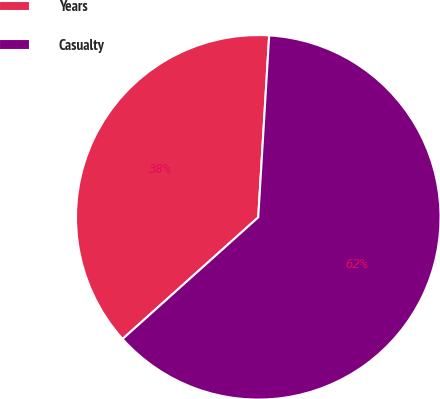Convert chart. <chart><loc_0><loc_0><loc_500><loc_500><pie_chart><fcel>Years<fcel>Casualty<nl><fcel>37.59%<fcel>62.41%<nl></chart> 